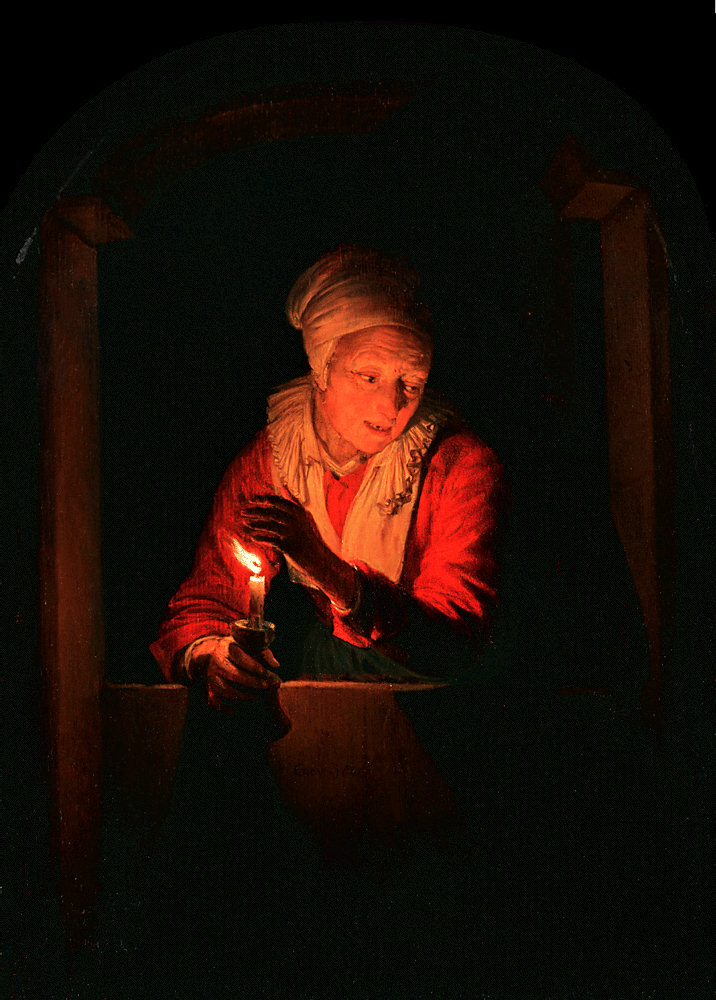How does the use of light influence the overall mood of the scene? The artist masterfully uses light to set a dramatic yet intimate mood. The candle's flame not only highlights the woman's face but also casts a warm glow against the darker, cooler background. This deliberate contrast creates a focal point around the woman and the candle, emphasizing a sense of warmth and solitude. The light symbolizes hope or enlightenment, standing out amid the surrounding darkness, which could be reflecting on life's struggles. 